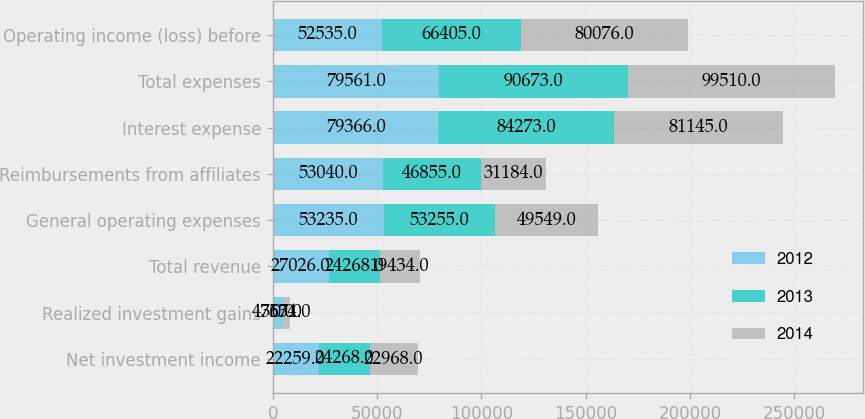<chart> <loc_0><loc_0><loc_500><loc_500><stacked_bar_chart><ecel><fcel>Net investment income<fcel>Realized investment gains<fcel>Total revenue<fcel>General operating expenses<fcel>Reimbursements from affiliates<fcel>Interest expense<fcel>Total expenses<fcel>Operating income (loss) before<nl><fcel>2012<fcel>22259<fcel>4767<fcel>27026<fcel>53235<fcel>53040<fcel>79366<fcel>79561<fcel>52535<nl><fcel>2013<fcel>24268<fcel>0<fcel>24268<fcel>53255<fcel>46855<fcel>84273<fcel>90673<fcel>66405<nl><fcel>2014<fcel>22968<fcel>3534<fcel>19434<fcel>49549<fcel>31184<fcel>81145<fcel>99510<fcel>80076<nl></chart> 